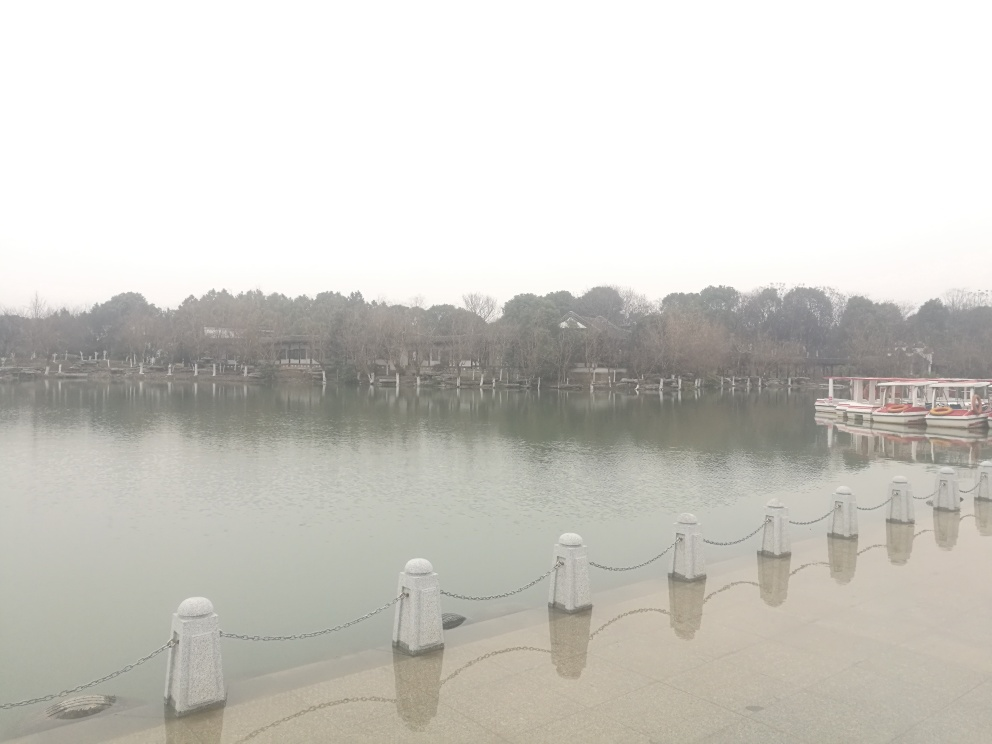Are there any human activities present in the image? No immediate evidence of human activity is observable. The boats are stationary and there are no visible people on the pier or in the surrounding area. This contributes to the image's overall stillness. Might this stillness indicate a particular time of day or season? The stillness could suggest an early morning timeframe before the area becomes busy, or it could indicate a colder season when there are generally fewer outdoor activities. 